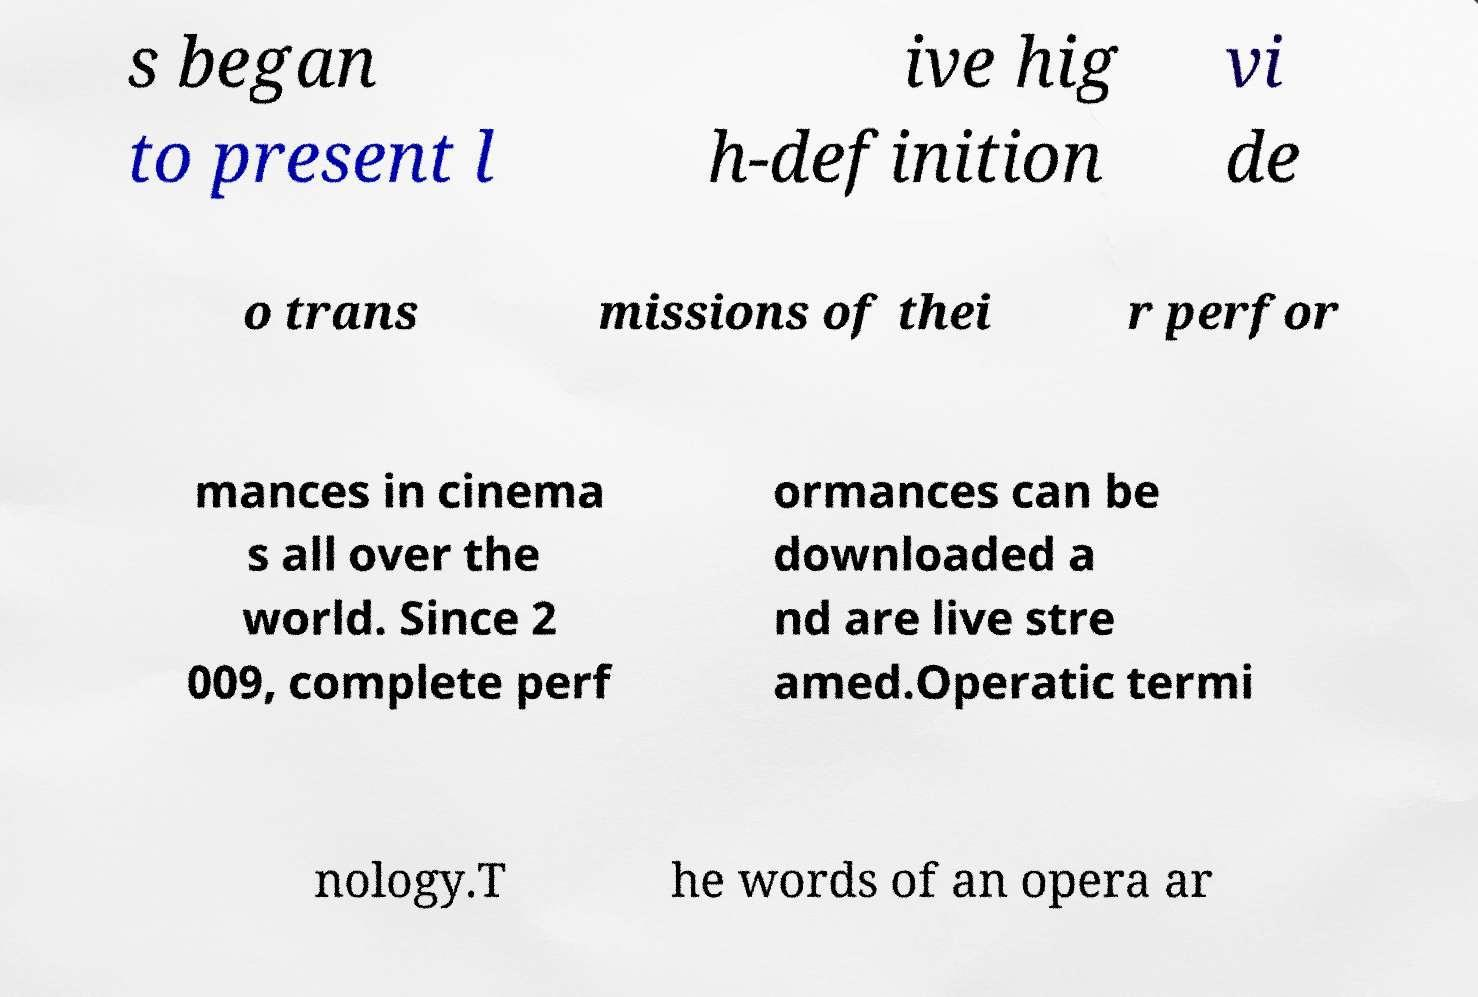Please read and relay the text visible in this image. What does it say? s began to present l ive hig h-definition vi de o trans missions of thei r perfor mances in cinema s all over the world. Since 2 009, complete perf ormances can be downloaded a nd are live stre amed.Operatic termi nology.T he words of an opera ar 